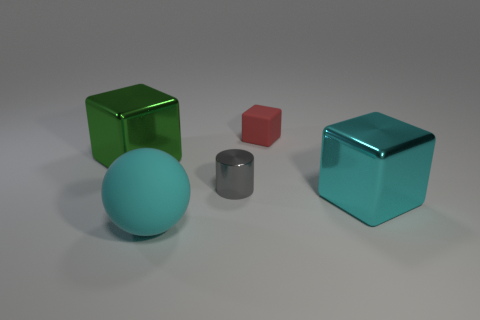There is a cyan thing left of the gray cylinder; does it have the same size as the gray metallic object?
Make the answer very short. No. What number of red things are small shiny cylinders or small objects?
Offer a terse response. 1. Are any blue metal things visible?
Your response must be concise. No. Is there a matte thing behind the large cyan thing that is left of the metal cube that is in front of the green thing?
Keep it short and to the point. Yes. There is a red rubber object; is its shape the same as the tiny gray thing that is right of the matte sphere?
Ensure brevity in your answer.  No. There is a big shiny block that is to the left of the block that is in front of the large metallic thing that is left of the red rubber object; what color is it?
Ensure brevity in your answer.  Green. How many objects are big metal objects that are to the left of the big cyan rubber thing or things that are to the left of the small red cube?
Provide a short and direct response. 3. What number of other objects are the same color as the small matte object?
Your answer should be very brief. 0. Do the big metallic thing right of the rubber block and the tiny red thing have the same shape?
Give a very brief answer. Yes. Are there fewer tiny metallic objects on the right side of the gray metal thing than small gray cylinders?
Ensure brevity in your answer.  Yes. 